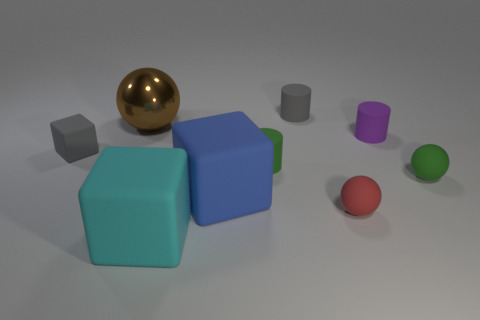The matte object that is the same color as the small block is what size?
Ensure brevity in your answer.  Small. The large object that is both left of the blue matte cube and in front of the tiny green matte ball has what shape?
Ensure brevity in your answer.  Cube. Is there anything else that is the same material as the brown sphere?
Your answer should be compact. No. The ball that is behind the red object and in front of the purple rubber thing is made of what material?
Keep it short and to the point. Rubber. There is a big cyan object that is made of the same material as the small purple object; what shape is it?
Provide a succinct answer. Cube. Are there any other things of the same color as the big ball?
Keep it short and to the point. No. Is the number of red matte spheres that are in front of the big shiny object greater than the number of large blue matte objects?
Offer a very short reply. No. What is the material of the cyan cube?
Provide a short and direct response. Rubber. How many gray matte objects are the same size as the cyan rubber thing?
Keep it short and to the point. 0. Are there the same number of brown balls behind the big brown metallic object and small things that are behind the blue block?
Offer a very short reply. No. 